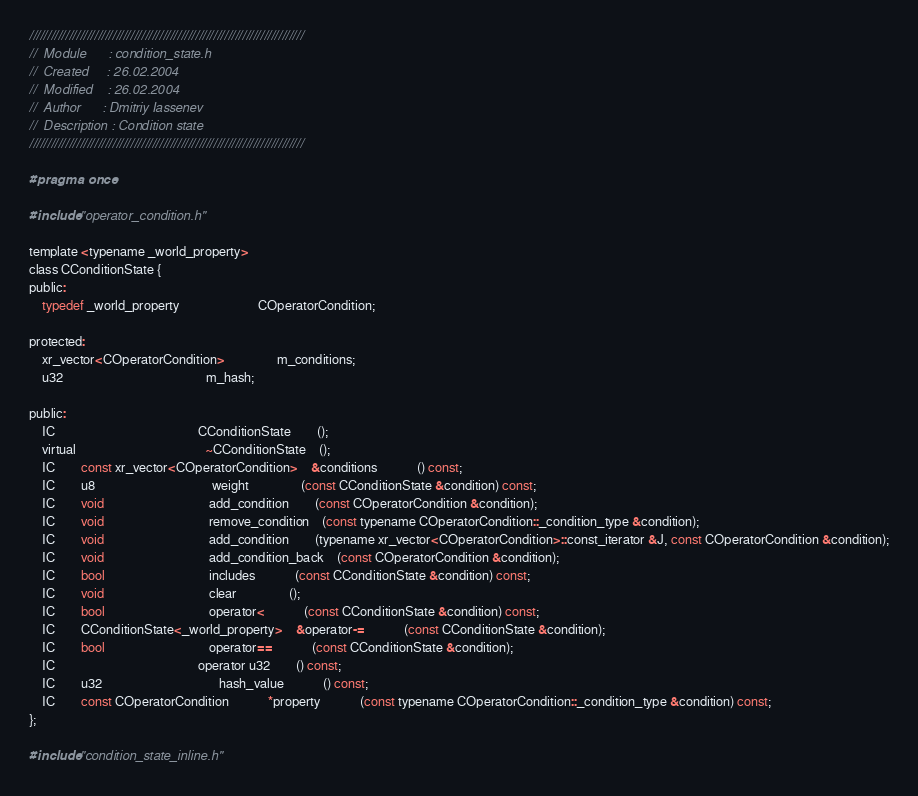<code> <loc_0><loc_0><loc_500><loc_500><_C_>////////////////////////////////////////////////////////////////////////////
//	Module 		: condition_state.h
//	Created 	: 26.02.2004
//  Modified 	: 26.02.2004
//	Author		: Dmitriy Iassenev
//	Description : Condition state
////////////////////////////////////////////////////////////////////////////

#pragma once

#include "operator_condition.h"

template <typename _world_property>
class CConditionState {
public:
	typedef _world_property						COperatorCondition;

protected:
	xr_vector<COperatorCondition>				m_conditions;
	u32											m_hash;

public:
	IC											CConditionState		();
	virtual										~CConditionState	();
	IC		const xr_vector<COperatorCondition>	&conditions			() const;
	IC		u8									weight				(const CConditionState &condition) const;
	IC		void								add_condition		(const COperatorCondition &condition);
	IC		void								remove_condition	(const typename COperatorCondition::_condition_type &condition);
	IC		void								add_condition		(typename xr_vector<COperatorCondition>::const_iterator &J, const COperatorCondition &condition);
	IC		void								add_condition_back	(const COperatorCondition &condition);
	IC		bool								includes			(const CConditionState &condition) const;
	IC		void								clear				();
	IC		bool								operator<			(const CConditionState &condition) const;
	IC		CConditionState<_world_property>	&operator-=			(const CConditionState &condition);
	IC		bool 								operator==			(const CConditionState &condition);
	IC											operator u32		() const;
	IC		u32									hash_value			() const;
	IC		const COperatorCondition			*property			(const typename COperatorCondition::_condition_type &condition) const;
};

#include "condition_state_inline.h"</code> 